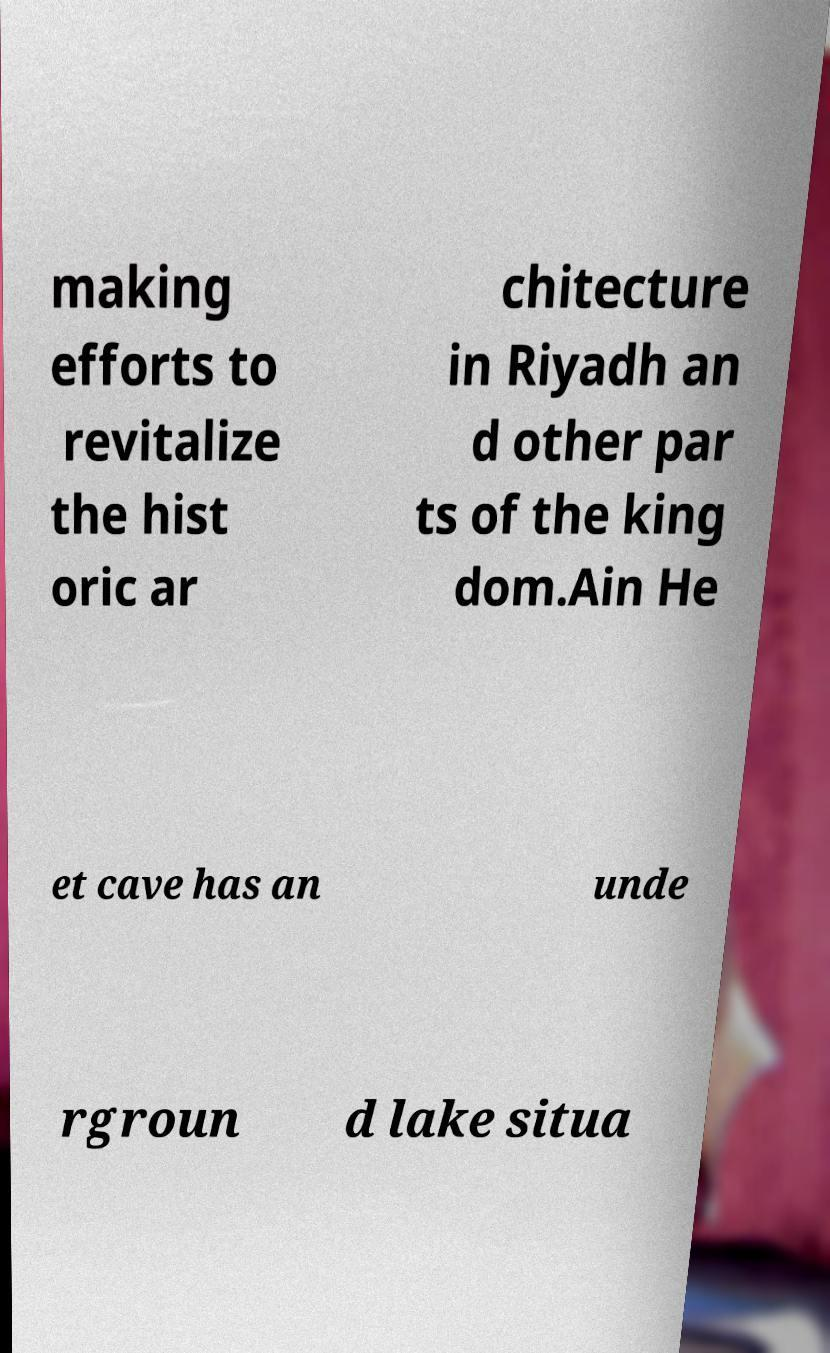For documentation purposes, I need the text within this image transcribed. Could you provide that? making efforts to revitalize the hist oric ar chitecture in Riyadh an d other par ts of the king dom.Ain He et cave has an unde rgroun d lake situa 